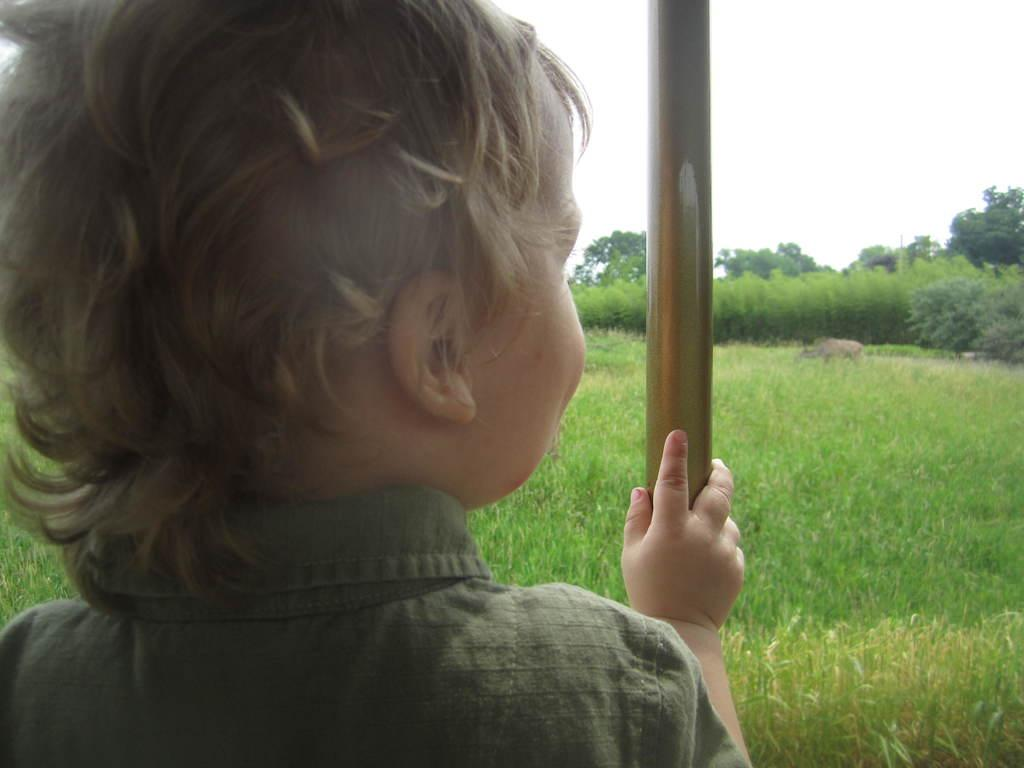What is the main subject in the front of the image? There is a child in the front of the image. What can be seen on the right side of the image? There is a pole on the right side of the image. What type of environment is visible in the background of the image? There is an open grass ground and multiple trees in the background of the image. What type of lace is used to decorate the property in the image? There is no property or lace present in the image. 